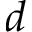Convert formula to latex. <formula><loc_0><loc_0><loc_500><loc_500>d</formula> 